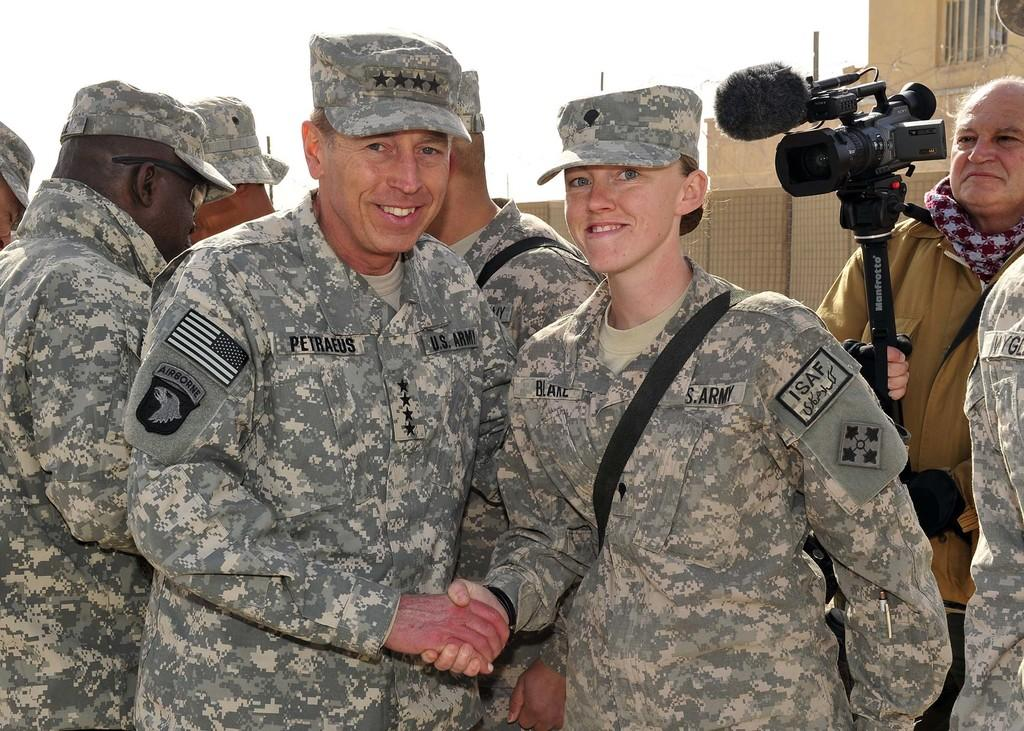What can be seen in the image? There is a group of soldiers in the image. Where is the person holding a camera located in the image? The person holding a camera is on the right side of the image. What is behind the person holding the camera? There is a building behind the person holding the camera. How many jars of sticky substance can be seen in the image? There are no jars of sticky substance present in the image. What time is displayed on the clocks in the image? There are no clocks present in the image. 